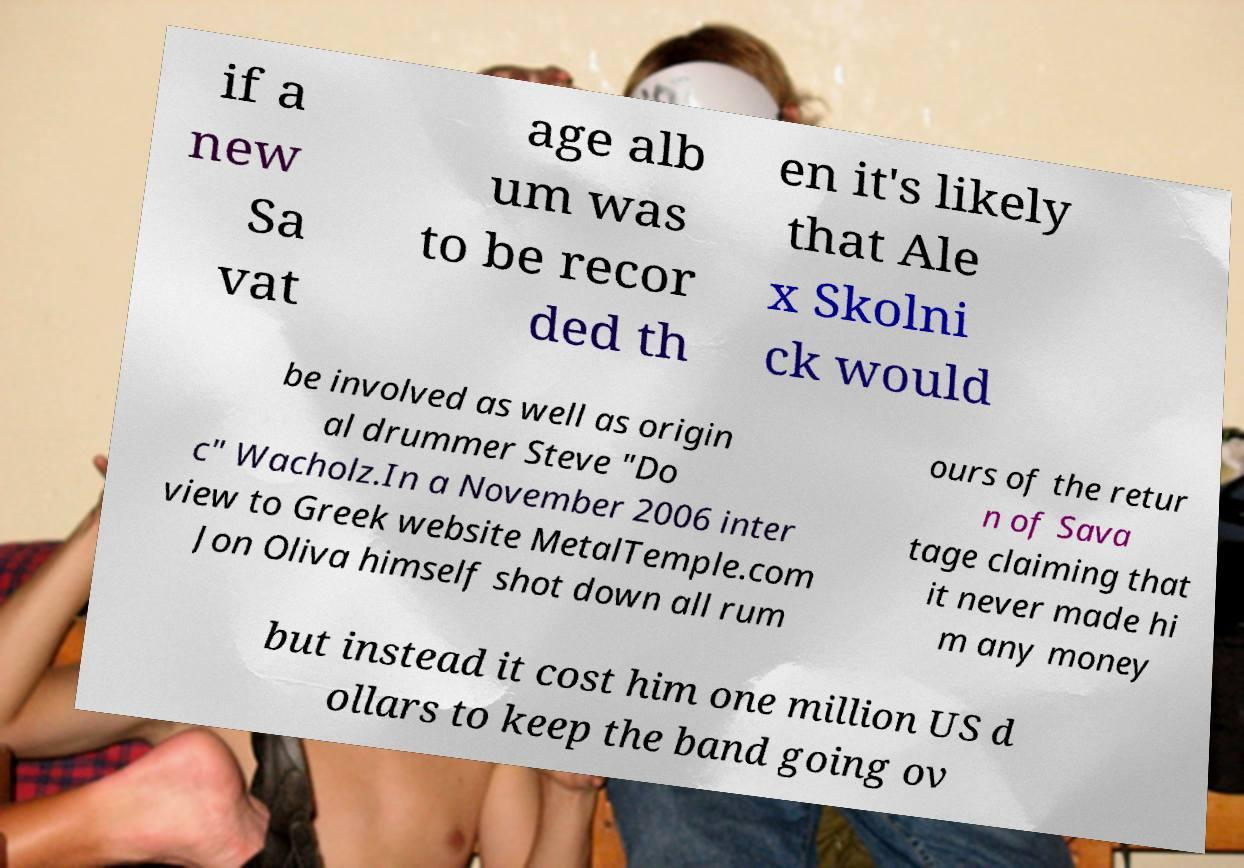Please identify and transcribe the text found in this image. if a new Sa vat age alb um was to be recor ded th en it's likely that Ale x Skolni ck would be involved as well as origin al drummer Steve "Do c" Wacholz.In a November 2006 inter view to Greek website MetalTemple.com Jon Oliva himself shot down all rum ours of the retur n of Sava tage claiming that it never made hi m any money but instead it cost him one million US d ollars to keep the band going ov 